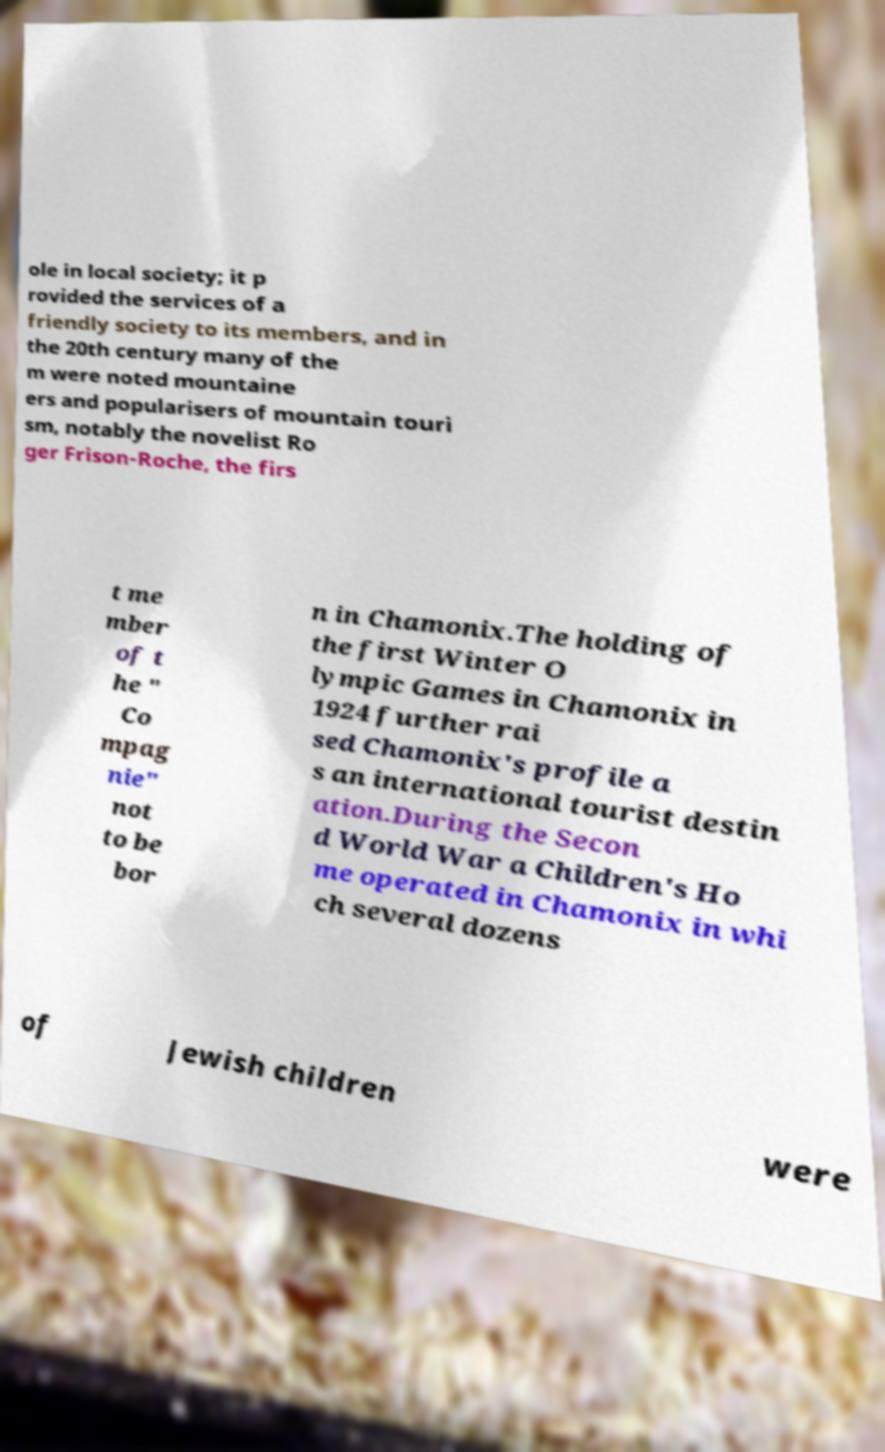Can you read and provide the text displayed in the image?This photo seems to have some interesting text. Can you extract and type it out for me? ole in local society; it p rovided the services of a friendly society to its members, and in the 20th century many of the m were noted mountaine ers and popularisers of mountain touri sm, notably the novelist Ro ger Frison-Roche, the firs t me mber of t he " Co mpag nie" not to be bor n in Chamonix.The holding of the first Winter O lympic Games in Chamonix in 1924 further rai sed Chamonix's profile a s an international tourist destin ation.During the Secon d World War a Children's Ho me operated in Chamonix in whi ch several dozens of Jewish children were 